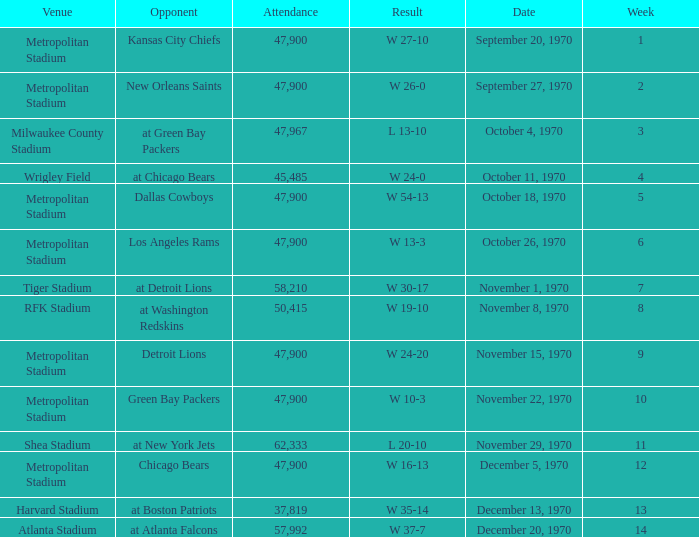How many people attended the game with a result of w 16-13 and a week earlier than 12? None. 